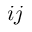Convert formula to latex. <formula><loc_0><loc_0><loc_500><loc_500>i j</formula> 